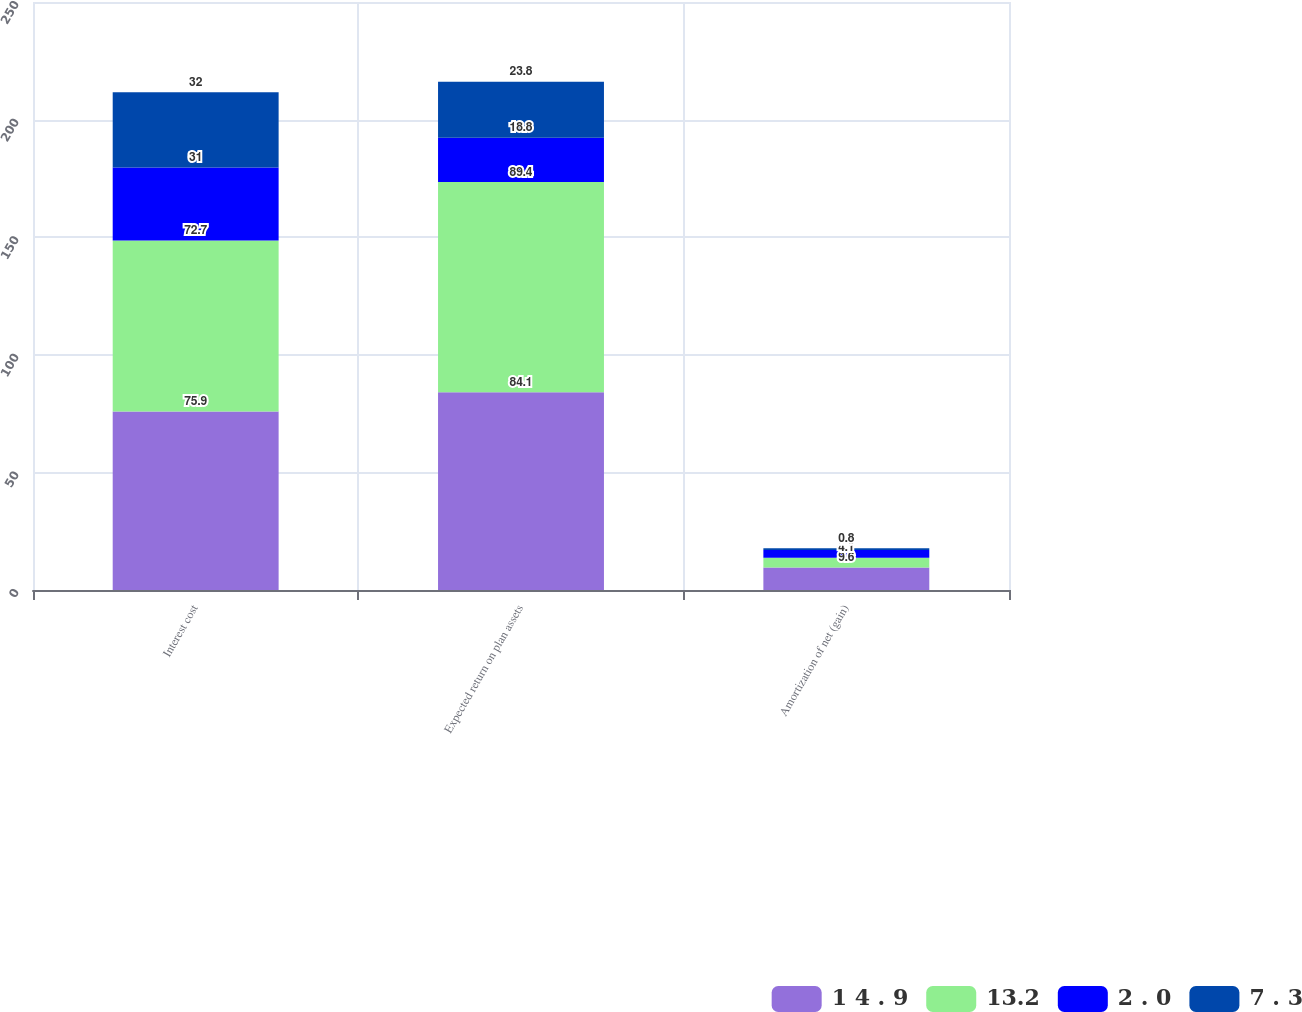<chart> <loc_0><loc_0><loc_500><loc_500><stacked_bar_chart><ecel><fcel>Interest cost<fcel>Expected return on plan assets<fcel>Amortization of net (gain)<nl><fcel>1 4 . 9<fcel>75.9<fcel>84.1<fcel>9.6<nl><fcel>13.2<fcel>72.7<fcel>89.4<fcel>4.1<nl><fcel>2 . 0<fcel>31<fcel>18.8<fcel>3.3<nl><fcel>7 . 3<fcel>32<fcel>23.8<fcel>0.8<nl></chart> 